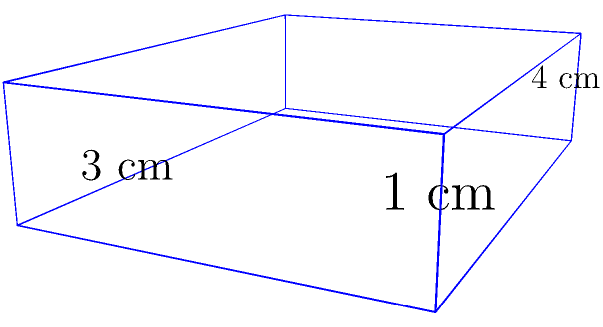A rectangular stone tablet covered in Phoenician alphabet characters is represented by a rectangular prism with dimensions 4 cm × 3 cm × 1 cm. What is the total length of all edges of this prism? To find the total edge length of the rectangular prism, we need to follow these steps:

1. Identify the number of edges:
   - A rectangular prism has 12 edges in total.

2. Categorize the edges by their lengths:
   - 4 edges with length 4 cm (along the length of the tablet)
   - 4 edges with length 3 cm (along the width of the tablet)
   - 4 edges with length 1 cm (along the height of the tablet)

3. Calculate the total length for each category:
   - Length edges: $4 \times 4$ cm $= 16$ cm
   - Width edges: $4 \times 3$ cm $= 12$ cm
   - Height edges: $4 \times 1$ cm $= 4$ cm

4. Sum up all the edge lengths:
   $$ \text{Total edge length} = 16 \text{ cm} + 12 \text{ cm} + 4 \text{ cm} = 32 \text{ cm} $$

Therefore, the total length of all edges of the rectangular prism representing the stone tablet is 32 cm.
Answer: 32 cm 